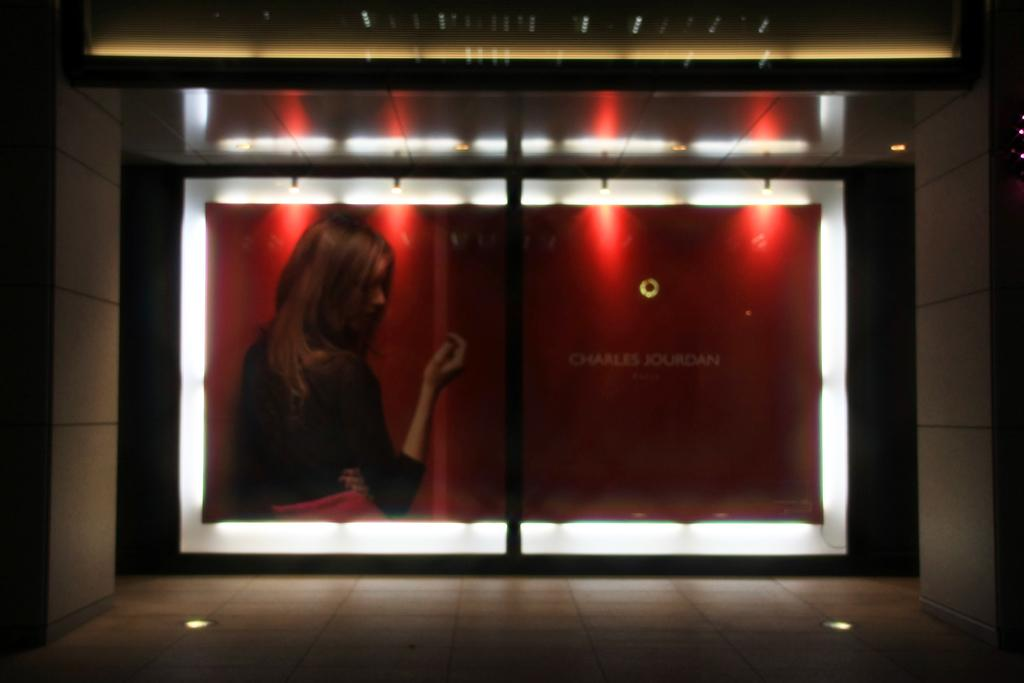What is on the wall in the image? There is a screen on the wall. What can be seen on the screen? A person's image is visible on the screen, along with some text. Are there any fairies visible in the image? No, there are no fairies present in the image. Is there a payment system visible in the image? No, there is no payment system visible in the image. 